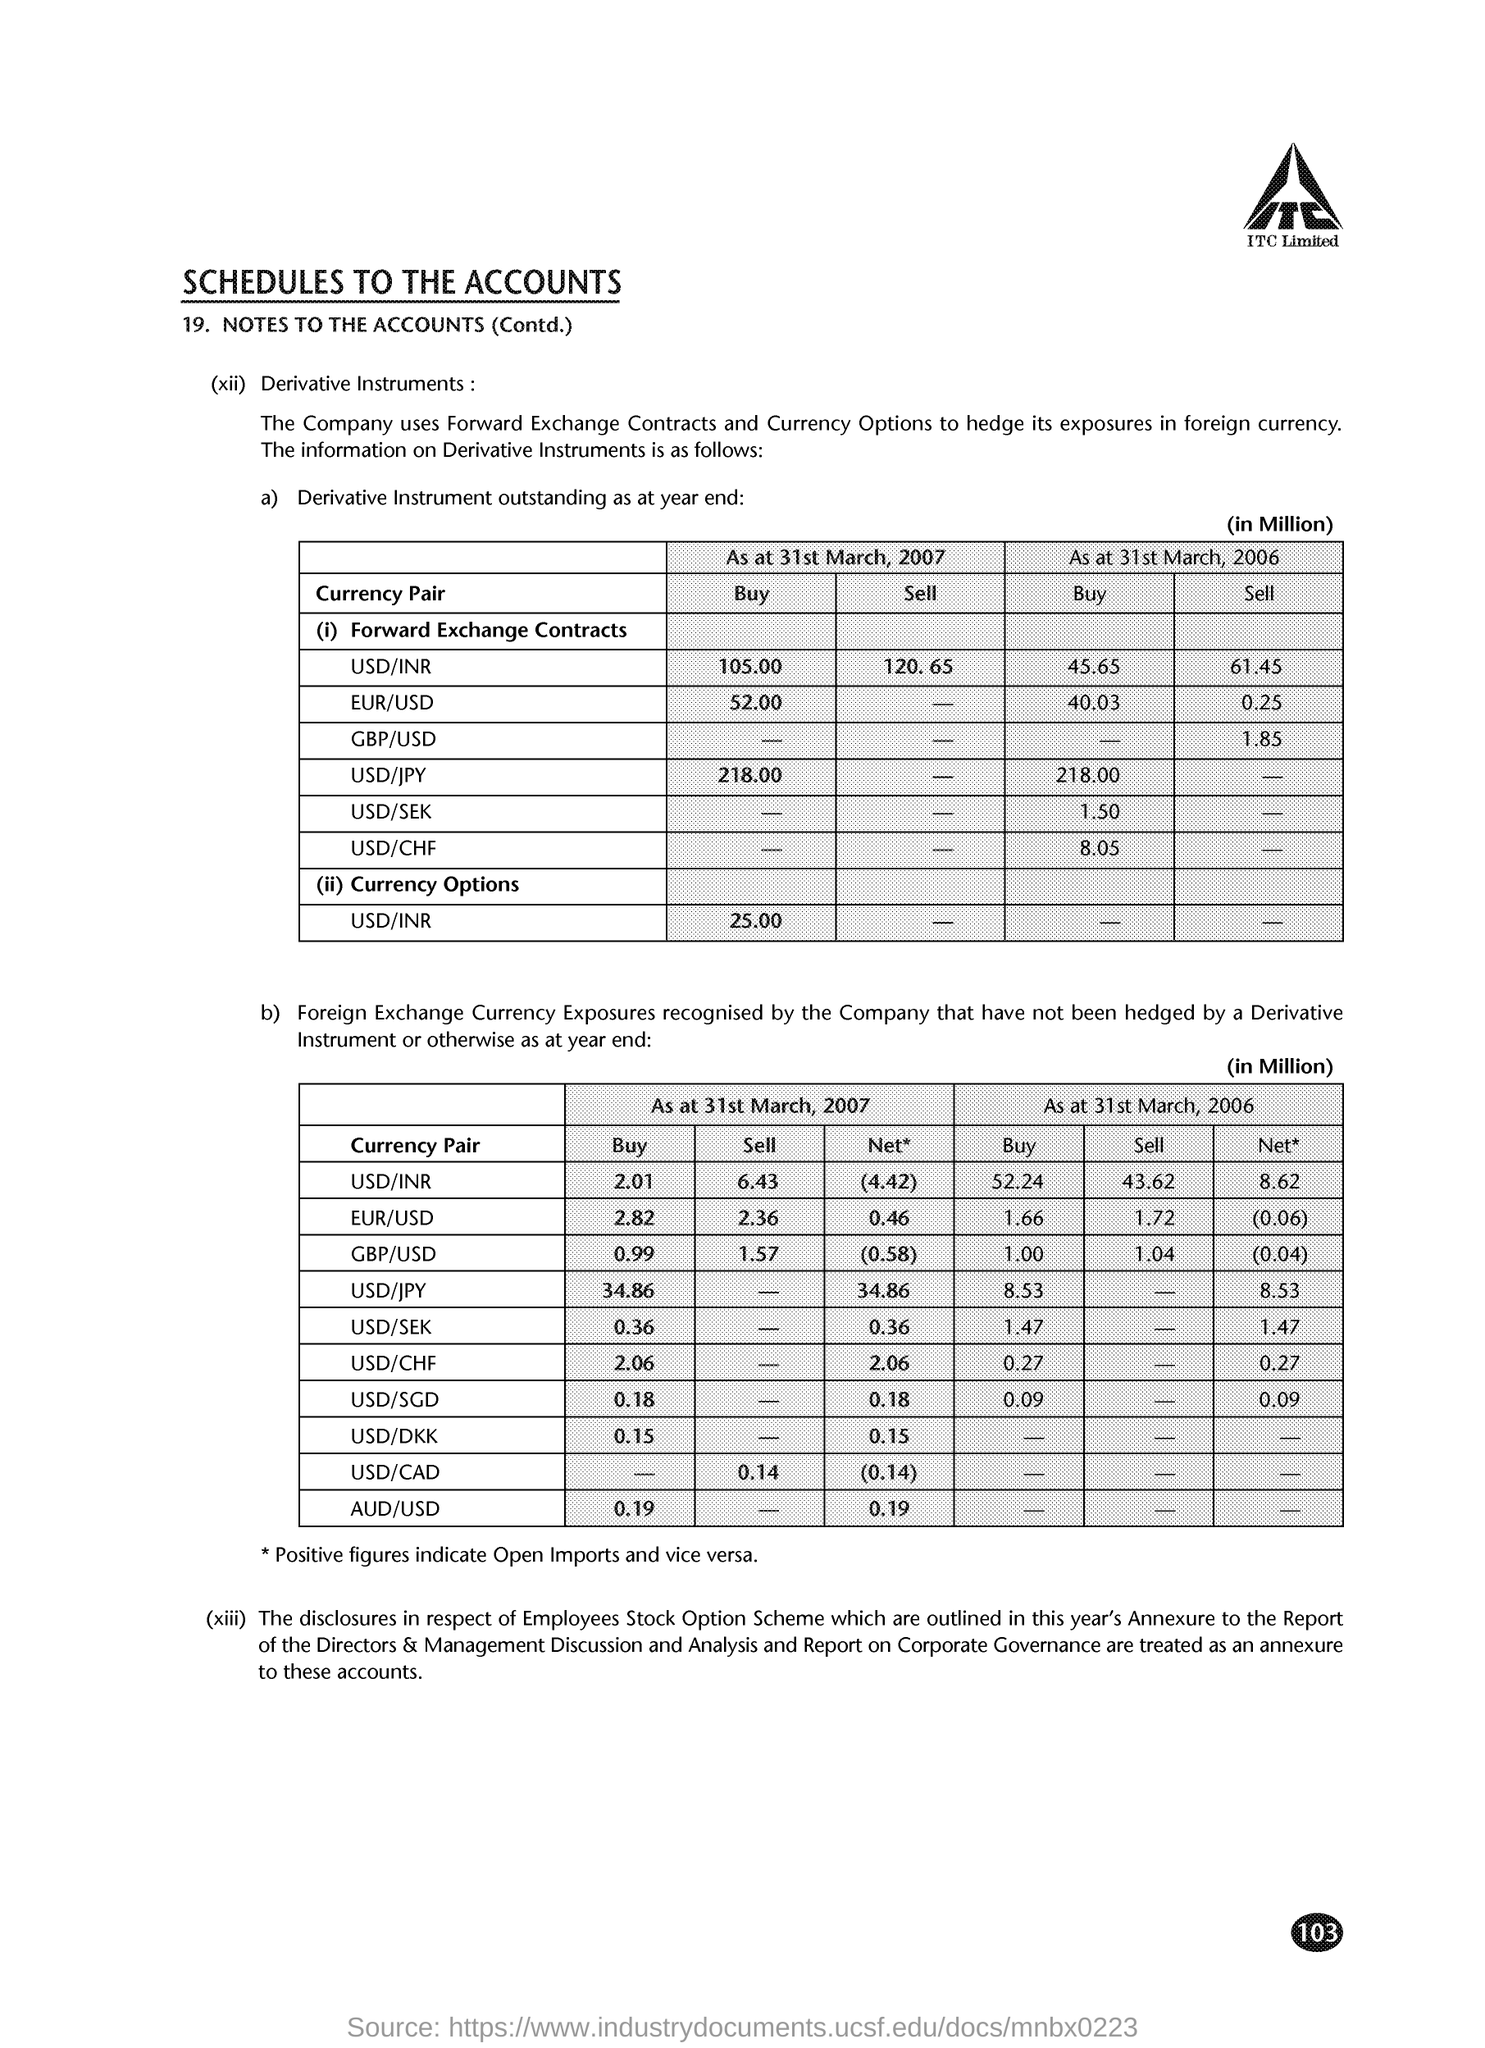Identify some key points in this picture. The company employs Forward Exchange Contracts and Currency Options to mitigate its exposure to fluctuations in foreign currencies. The page number on this document is 103. ITC Limited is the company whose name appears at the top of the page. 